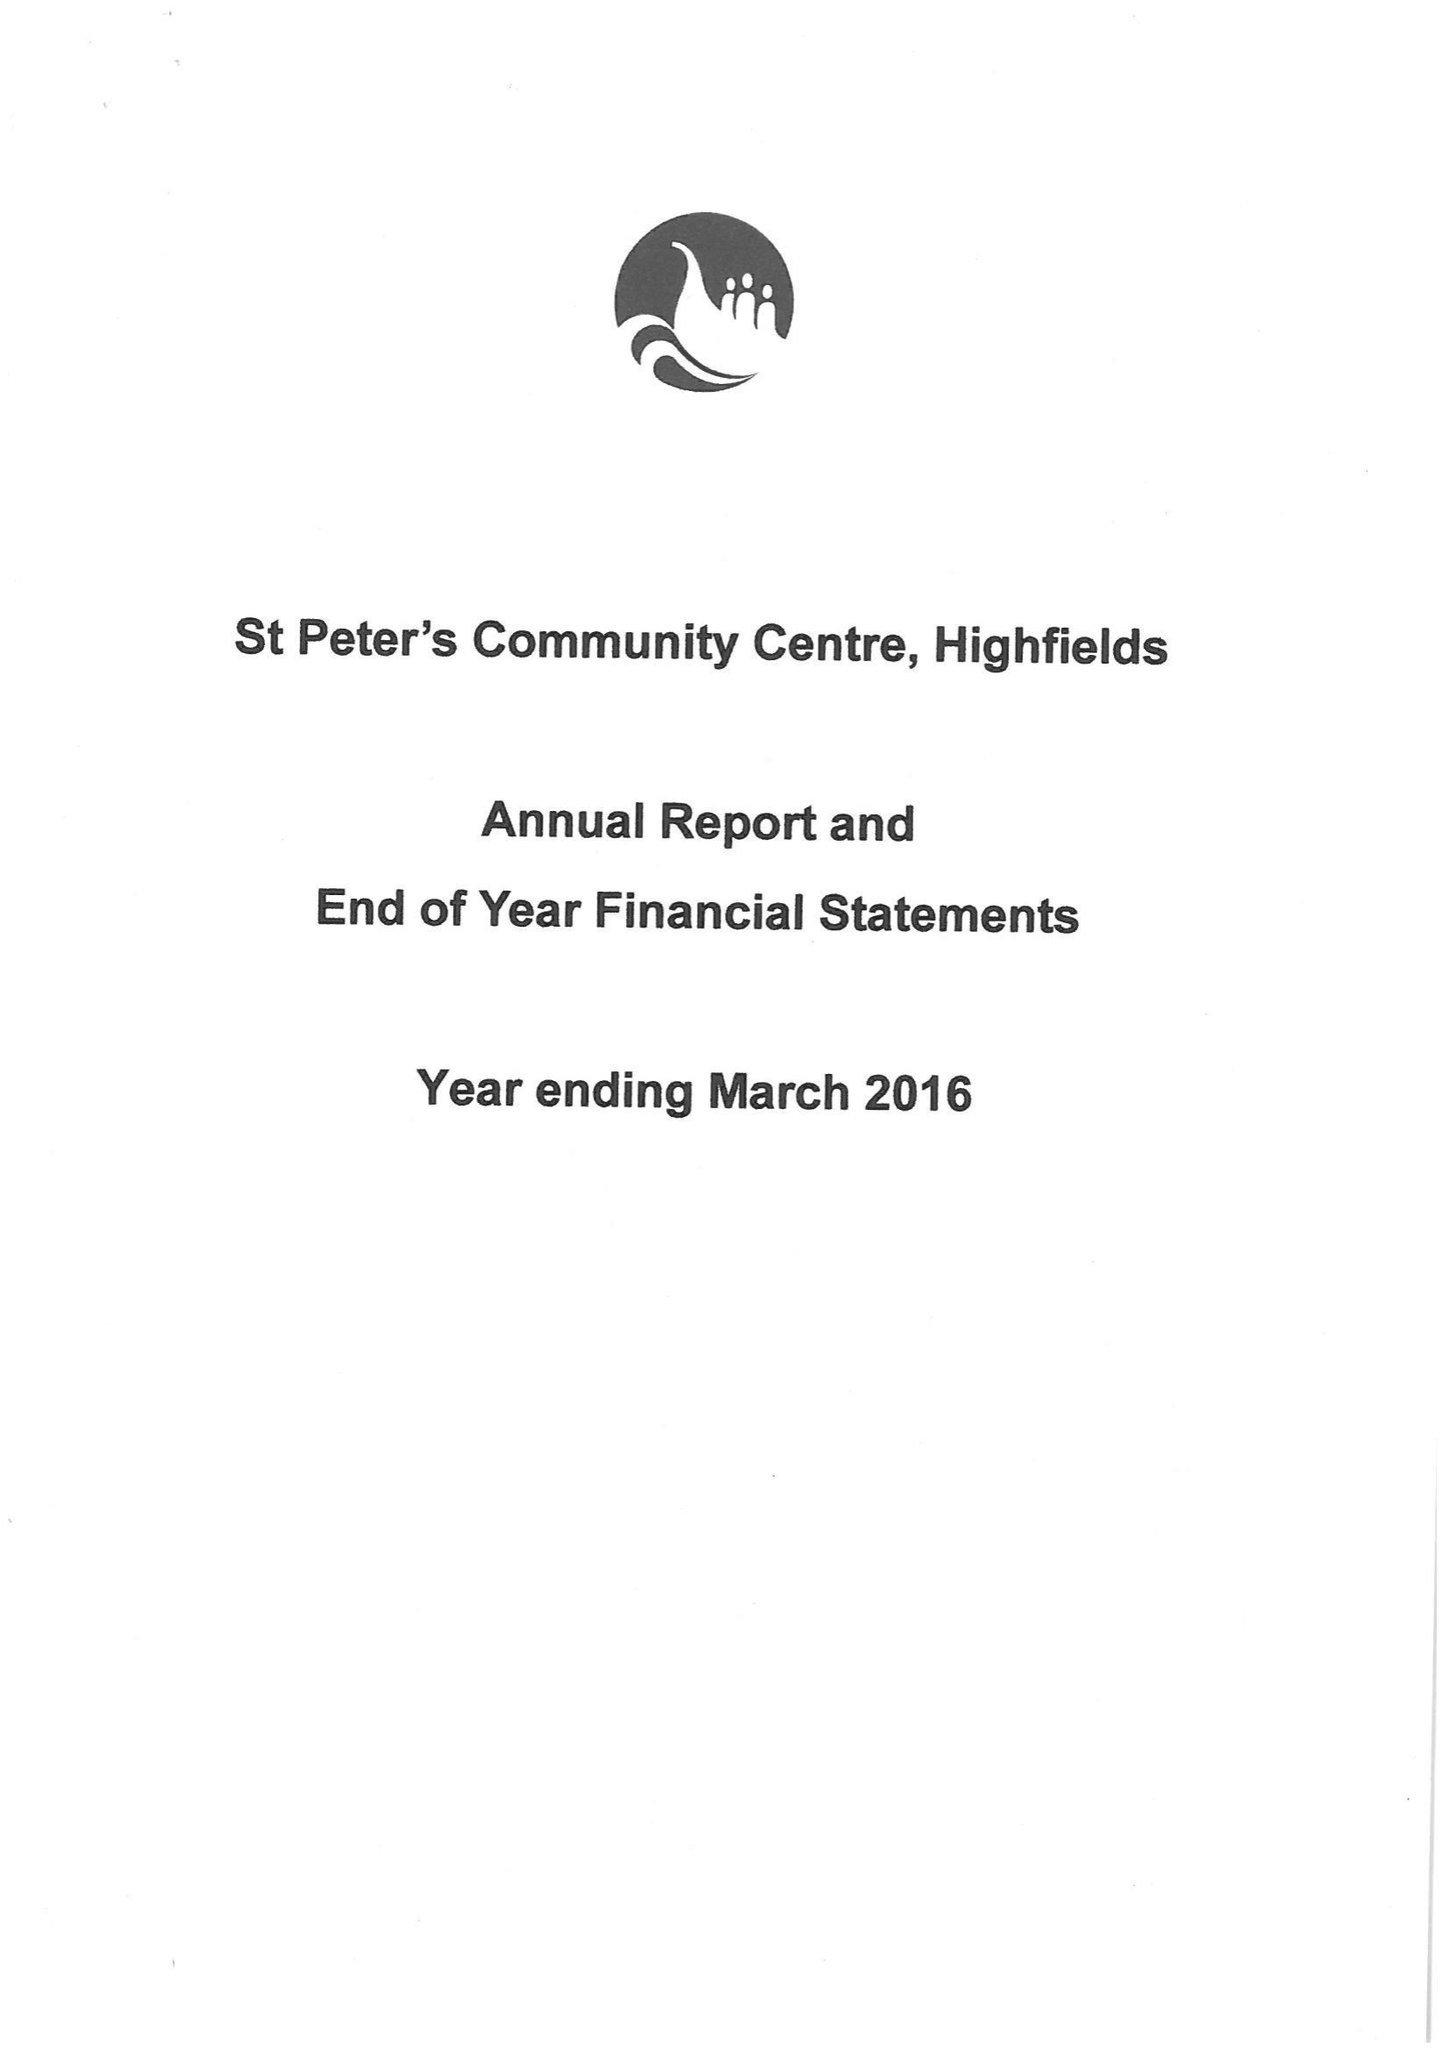What is the value for the spending_annually_in_british_pounds?
Answer the question using a single word or phrase. 25884.87 